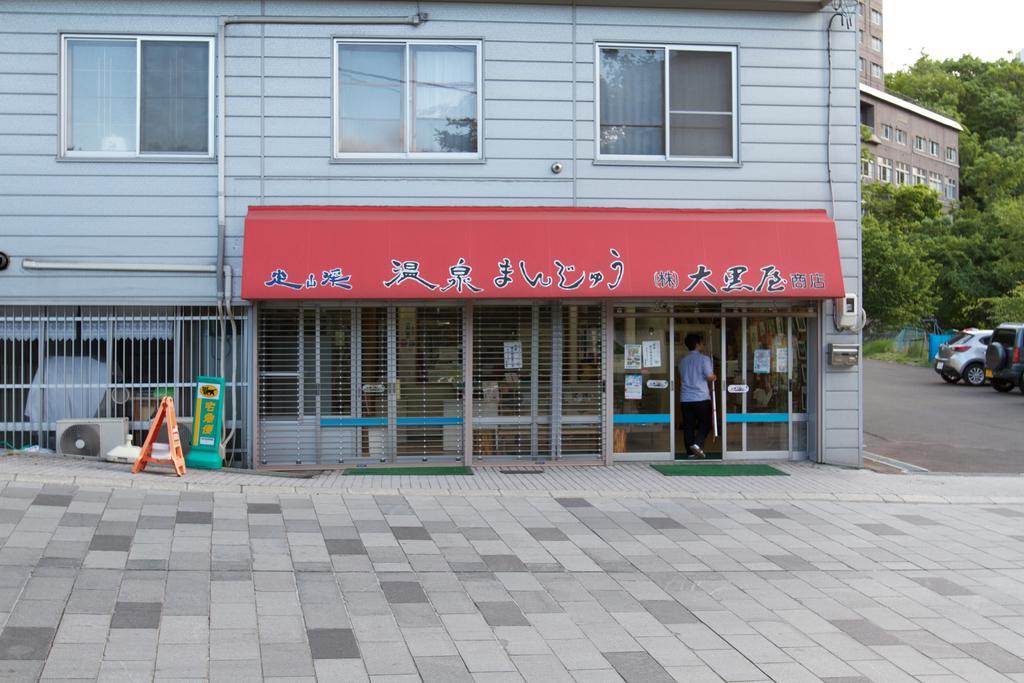Please provide a concise description of this image. In this picture there is a blue color Chinese shop with red naming board on the top. In the front there is a man with blue color shirt is opening the shop door. Beside we can see some cars are parked and few trees. 